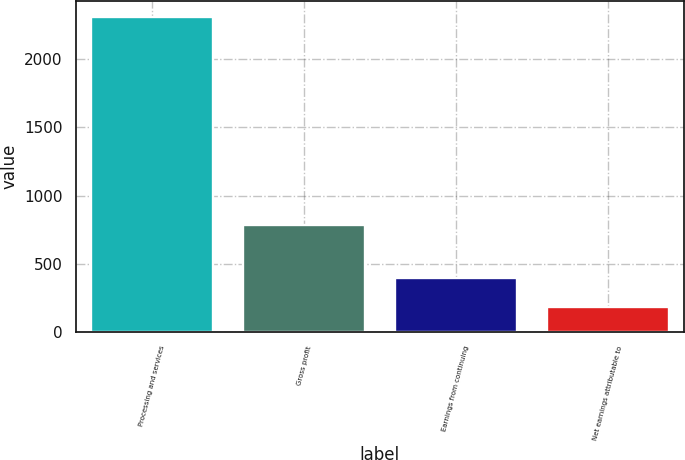Convert chart. <chart><loc_0><loc_0><loc_500><loc_500><bar_chart><fcel>Processing and services<fcel>Gross profit<fcel>Earnings from continuing<fcel>Net earnings attributable to<nl><fcel>2309<fcel>782<fcel>397.4<fcel>185<nl></chart> 